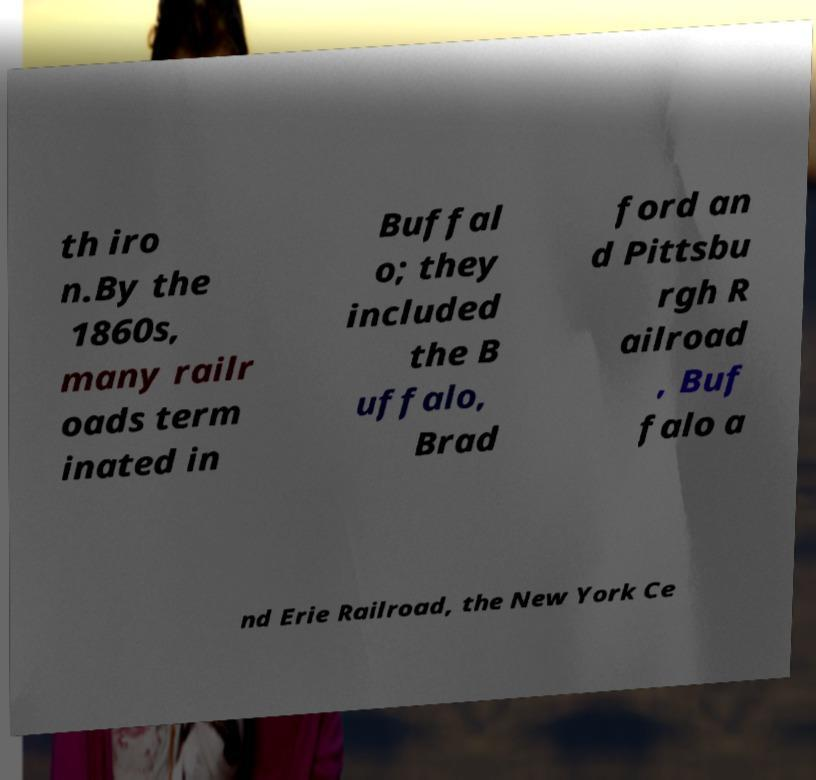For documentation purposes, I need the text within this image transcribed. Could you provide that? th iro n.By the 1860s, many railr oads term inated in Buffal o; they included the B uffalo, Brad ford an d Pittsbu rgh R ailroad , Buf falo a nd Erie Railroad, the New York Ce 